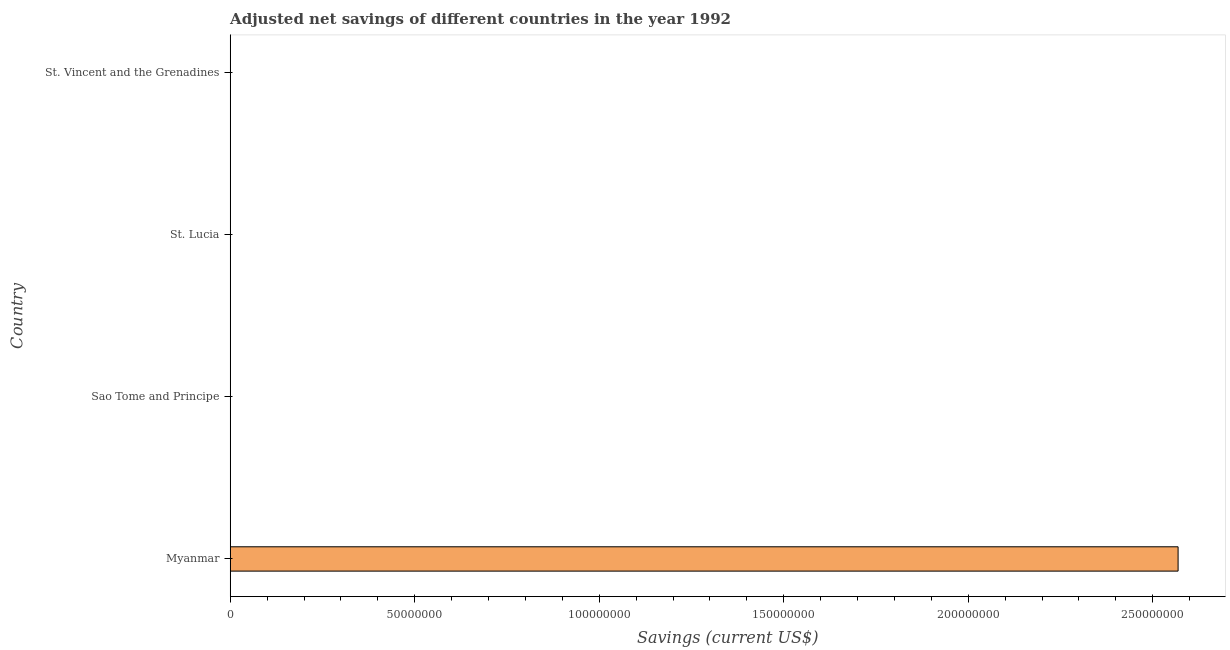Does the graph contain any zero values?
Your response must be concise. No. Does the graph contain grids?
Make the answer very short. No. What is the title of the graph?
Keep it short and to the point. Adjusted net savings of different countries in the year 1992. What is the label or title of the X-axis?
Your response must be concise. Savings (current US$). What is the adjusted net savings in St. Lucia?
Provide a short and direct response. 2.36e+04. Across all countries, what is the maximum adjusted net savings?
Keep it short and to the point. 2.57e+08. Across all countries, what is the minimum adjusted net savings?
Provide a short and direct response. 5390.67. In which country was the adjusted net savings maximum?
Give a very brief answer. Myanmar. In which country was the adjusted net savings minimum?
Give a very brief answer. Sao Tome and Principe. What is the sum of the adjusted net savings?
Offer a terse response. 2.57e+08. What is the difference between the adjusted net savings in Sao Tome and Principe and St. Lucia?
Your answer should be very brief. -1.82e+04. What is the average adjusted net savings per country?
Your response must be concise. 6.42e+07. What is the median adjusted net savings?
Your answer should be compact. 3.59e+04. What is the ratio of the adjusted net savings in Myanmar to that in Sao Tome and Principe?
Offer a terse response. 4.76e+04. Is the difference between the adjusted net savings in Myanmar and St. Vincent and the Grenadines greater than the difference between any two countries?
Your answer should be compact. No. What is the difference between the highest and the second highest adjusted net savings?
Give a very brief answer. 2.57e+08. What is the difference between the highest and the lowest adjusted net savings?
Your answer should be very brief. 2.57e+08. In how many countries, is the adjusted net savings greater than the average adjusted net savings taken over all countries?
Offer a terse response. 1. How many bars are there?
Give a very brief answer. 4. Are all the bars in the graph horizontal?
Your answer should be compact. Yes. What is the difference between two consecutive major ticks on the X-axis?
Your answer should be very brief. 5.00e+07. What is the Savings (current US$) of Myanmar?
Your answer should be very brief. 2.57e+08. What is the Savings (current US$) in Sao Tome and Principe?
Your answer should be very brief. 5390.67. What is the Savings (current US$) in St. Lucia?
Provide a short and direct response. 2.36e+04. What is the Savings (current US$) in St. Vincent and the Grenadines?
Offer a very short reply. 4.83e+04. What is the difference between the Savings (current US$) in Myanmar and Sao Tome and Principe?
Ensure brevity in your answer.  2.57e+08. What is the difference between the Savings (current US$) in Myanmar and St. Lucia?
Your answer should be very brief. 2.57e+08. What is the difference between the Savings (current US$) in Myanmar and St. Vincent and the Grenadines?
Give a very brief answer. 2.57e+08. What is the difference between the Savings (current US$) in Sao Tome and Principe and St. Lucia?
Make the answer very short. -1.82e+04. What is the difference between the Savings (current US$) in Sao Tome and Principe and St. Vincent and the Grenadines?
Keep it short and to the point. -4.29e+04. What is the difference between the Savings (current US$) in St. Lucia and St. Vincent and the Grenadines?
Give a very brief answer. -2.47e+04. What is the ratio of the Savings (current US$) in Myanmar to that in Sao Tome and Principe?
Ensure brevity in your answer.  4.76e+04. What is the ratio of the Savings (current US$) in Myanmar to that in St. Lucia?
Give a very brief answer. 1.09e+04. What is the ratio of the Savings (current US$) in Myanmar to that in St. Vincent and the Grenadines?
Offer a terse response. 5317.31. What is the ratio of the Savings (current US$) in Sao Tome and Principe to that in St. Lucia?
Keep it short and to the point. 0.23. What is the ratio of the Savings (current US$) in Sao Tome and Principe to that in St. Vincent and the Grenadines?
Your response must be concise. 0.11. What is the ratio of the Savings (current US$) in St. Lucia to that in St. Vincent and the Grenadines?
Offer a terse response. 0.49. 